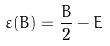Convert formula to latex. <formula><loc_0><loc_0><loc_500><loc_500>\varepsilon ( B ) = \frac { B } { 2 } - E</formula> 